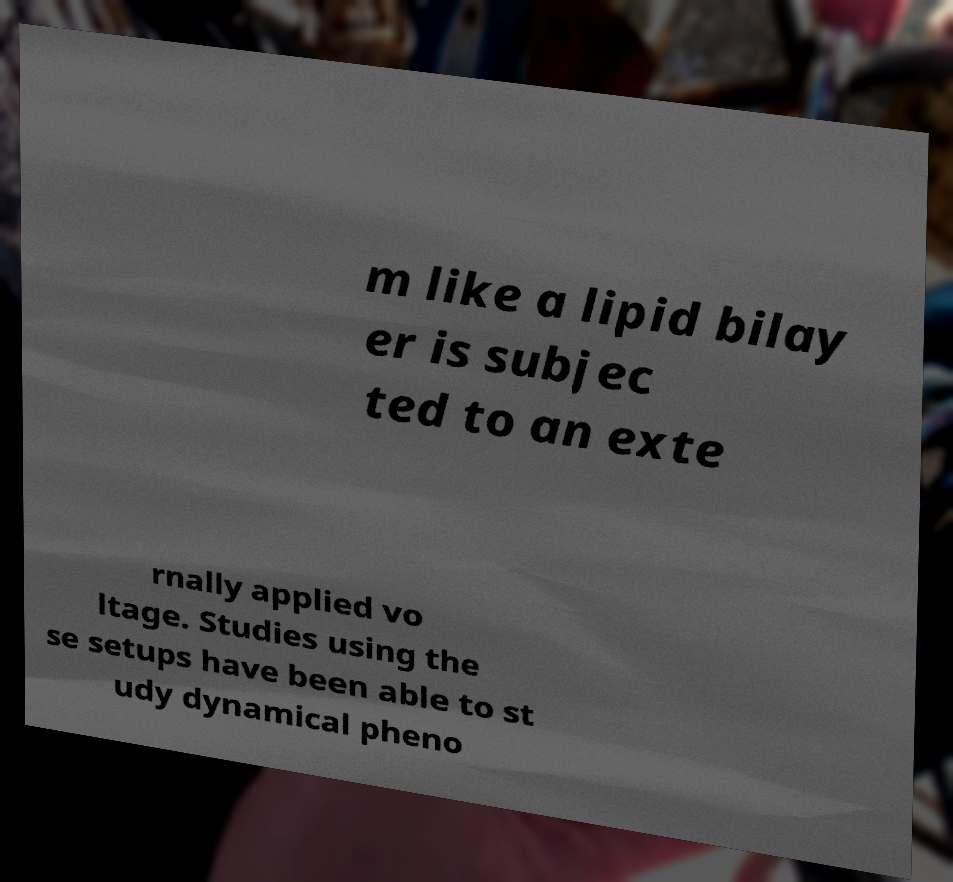Can you read and provide the text displayed in the image?This photo seems to have some interesting text. Can you extract and type it out for me? m like a lipid bilay er is subjec ted to an exte rnally applied vo ltage. Studies using the se setups have been able to st udy dynamical pheno 